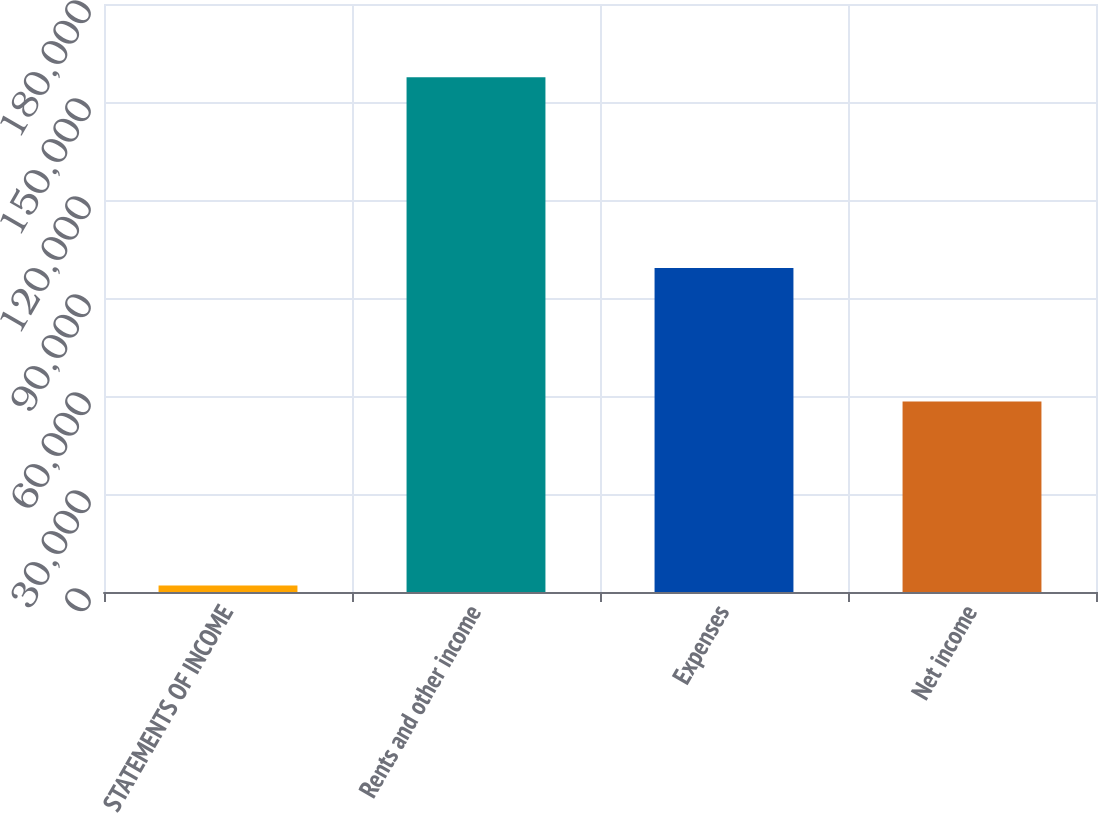Convert chart. <chart><loc_0><loc_0><loc_500><loc_500><bar_chart><fcel>STATEMENTS OF INCOME<fcel>Rents and other income<fcel>Expenses<fcel>Net income<nl><fcel>2005<fcel>157558<fcel>99211<fcel>58347<nl></chart> 